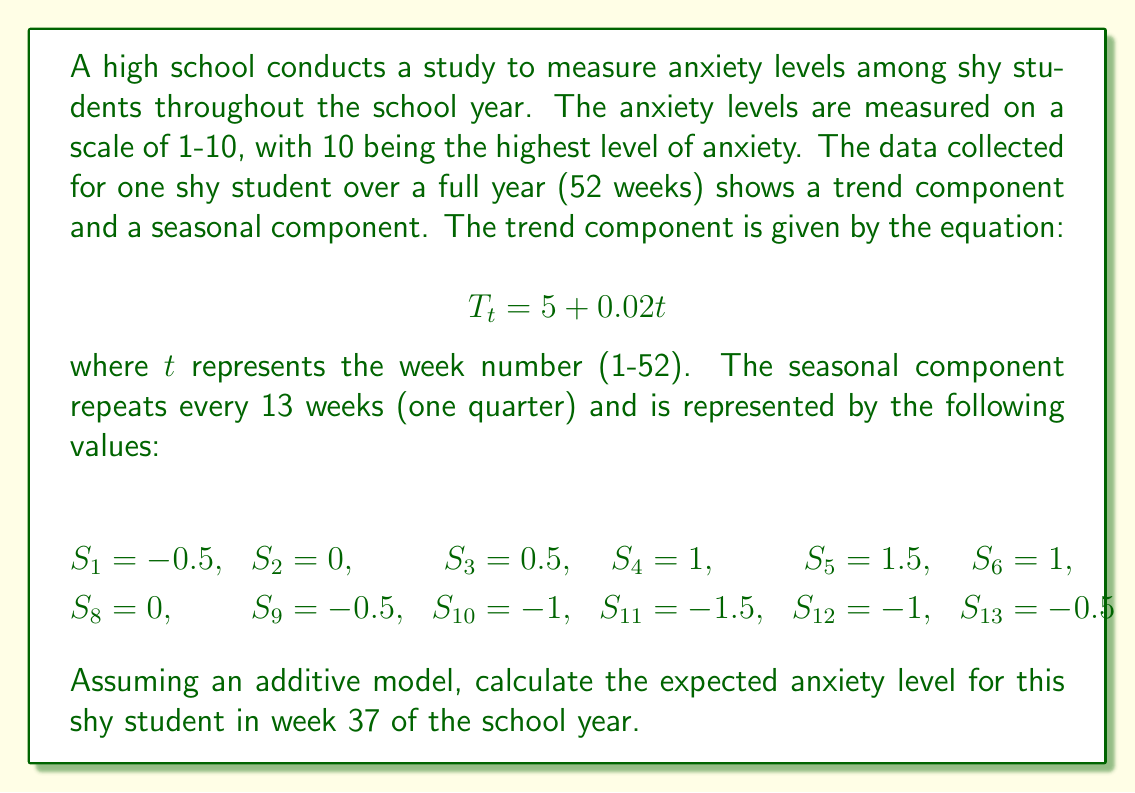What is the answer to this math problem? To solve this problem, we'll follow these steps:

1. Calculate the trend component for week 37
2. Determine the seasonal component for week 37
3. Add the trend and seasonal components

Step 1: Calculate the trend component
The trend component is given by the equation $T_t = 5 + 0.02t$
For week 37:
$$T_{37} = 5 + 0.02(37) = 5 + 0.74 = 5.74$$

Step 2: Determine the seasonal component
The seasonal component repeats every 13 weeks. To find the corresponding seasonal value for week 37, we need to find the remainder when 37 is divided by 13:

$37 \div 13 = 2$ remainder $11$

This means week 37 corresponds to week 11 in the seasonal pattern. From the given seasonal values, we see that $S_{11} = -1.5$

Step 3: Add the trend and seasonal components
In an additive model, we simply add the trend and seasonal components:

Expected anxiety level = Trend + Seasonal
$$= T_{37} + S_{11} = 5.74 + (-1.5) = 4.24$$

Therefore, the expected anxiety level for the shy student in week 37 is 4.24 on the 1-10 scale.
Answer: 4.24 